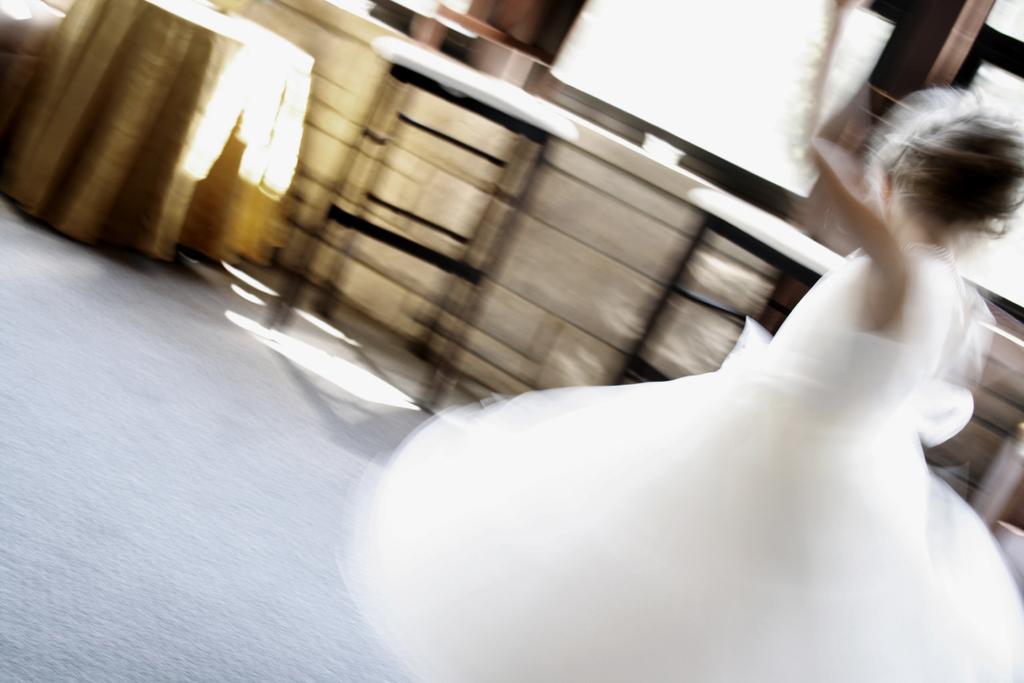Describe this image in one or two sentences. On the right side of the image a person is standing. At the top of the image we can see a table, cloth, chair, window are present. At the bottom of the image floor is there. 